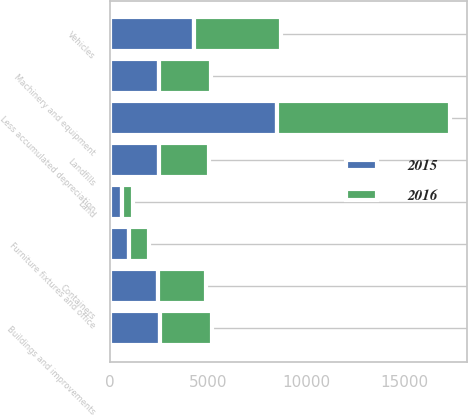Convert chart. <chart><loc_0><loc_0><loc_500><loc_500><stacked_bar_chart><ecel><fcel>Land<fcel>Landfills<fcel>Vehicles<fcel>Machinery and equipment<fcel>Containers<fcel>Buildings and improvements<fcel>Furniture fixtures and office<fcel>Less accumulated depreciation<nl><fcel>2016<fcel>608<fcel>2522.5<fcel>4433<fcel>2639<fcel>2469<fcel>2667<fcel>1010<fcel>8812<nl><fcel>2015<fcel>592<fcel>2522.5<fcel>4257<fcel>2499<fcel>2426<fcel>2546<fcel>993<fcel>8495<nl></chart> 